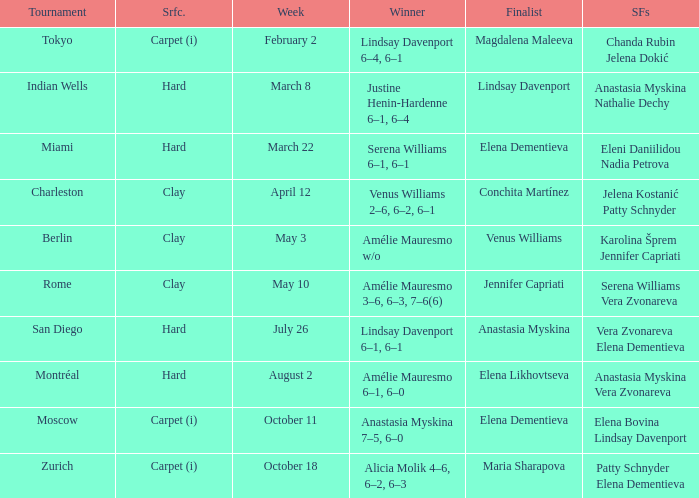Who was the winner of the Miami tournament where Elena Dementieva was a finalist? Serena Williams 6–1, 6–1. Could you parse the entire table? {'header': ['Tournament', 'Srfc.', 'Week', 'Winner', 'Finalist', 'SFs'], 'rows': [['Tokyo', 'Carpet (i)', 'February 2', 'Lindsay Davenport 6–4, 6–1', 'Magdalena Maleeva', 'Chanda Rubin Jelena Dokić'], ['Indian Wells', 'Hard', 'March 8', 'Justine Henin-Hardenne 6–1, 6–4', 'Lindsay Davenport', 'Anastasia Myskina Nathalie Dechy'], ['Miami', 'Hard', 'March 22', 'Serena Williams 6–1, 6–1', 'Elena Dementieva', 'Eleni Daniilidou Nadia Petrova'], ['Charleston', 'Clay', 'April 12', 'Venus Williams 2–6, 6–2, 6–1', 'Conchita Martínez', 'Jelena Kostanić Patty Schnyder'], ['Berlin', 'Clay', 'May 3', 'Amélie Mauresmo w/o', 'Venus Williams', 'Karolina Šprem Jennifer Capriati'], ['Rome', 'Clay', 'May 10', 'Amélie Mauresmo 3–6, 6–3, 7–6(6)', 'Jennifer Capriati', 'Serena Williams Vera Zvonareva'], ['San Diego', 'Hard', 'July 26', 'Lindsay Davenport 6–1, 6–1', 'Anastasia Myskina', 'Vera Zvonareva Elena Dementieva'], ['Montréal', 'Hard', 'August 2', 'Amélie Mauresmo 6–1, 6–0', 'Elena Likhovtseva', 'Anastasia Myskina Vera Zvonareva'], ['Moscow', 'Carpet (i)', 'October 11', 'Anastasia Myskina 7–5, 6–0', 'Elena Dementieva', 'Elena Bovina Lindsay Davenport'], ['Zurich', 'Carpet (i)', 'October 18', 'Alicia Molik 4–6, 6–2, 6–3', 'Maria Sharapova', 'Patty Schnyder Elena Dementieva']]} 